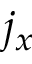<formula> <loc_0><loc_0><loc_500><loc_500>j _ { x }</formula> 